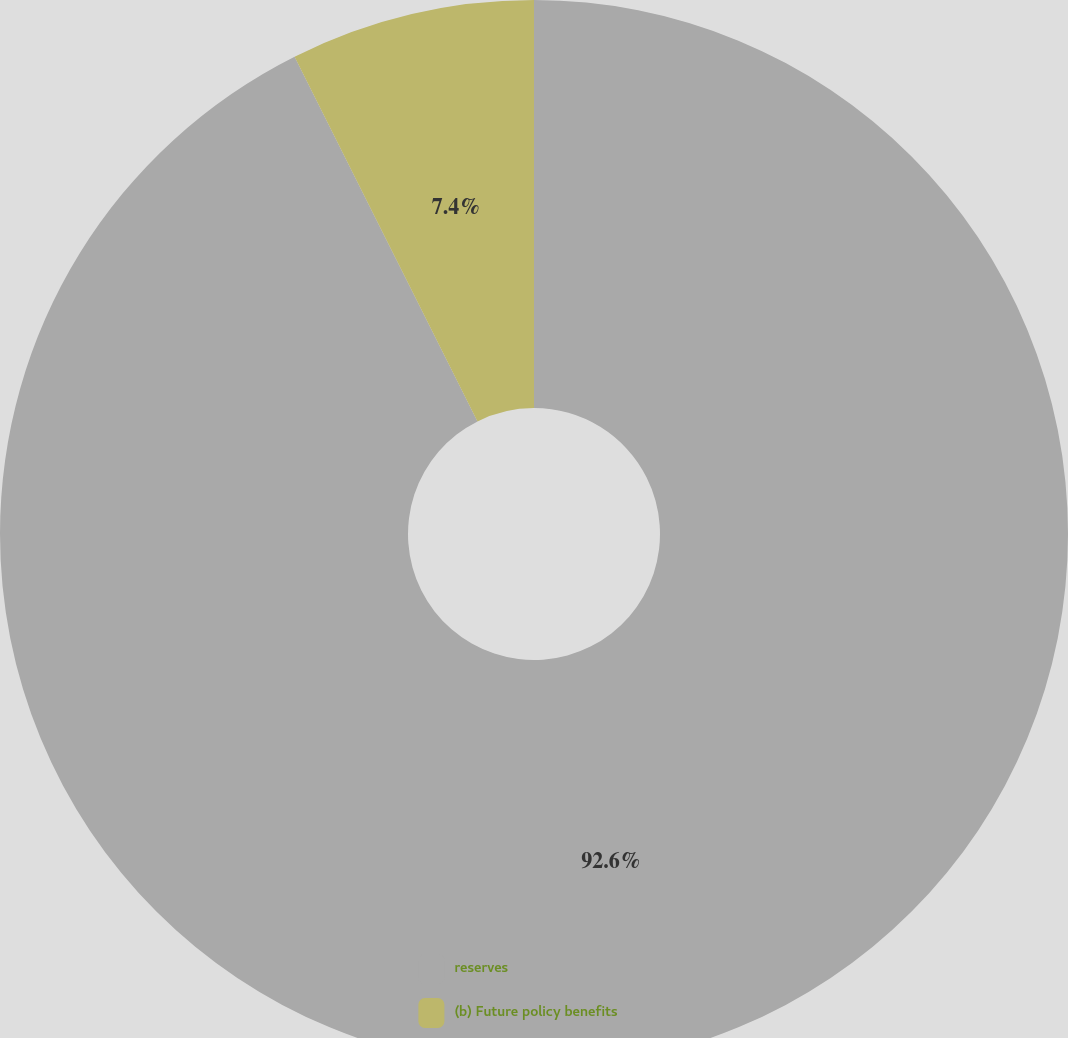<chart> <loc_0><loc_0><loc_500><loc_500><pie_chart><fcel>reserves<fcel>(b) Future policy benefits<nl><fcel>92.6%<fcel>7.4%<nl></chart> 